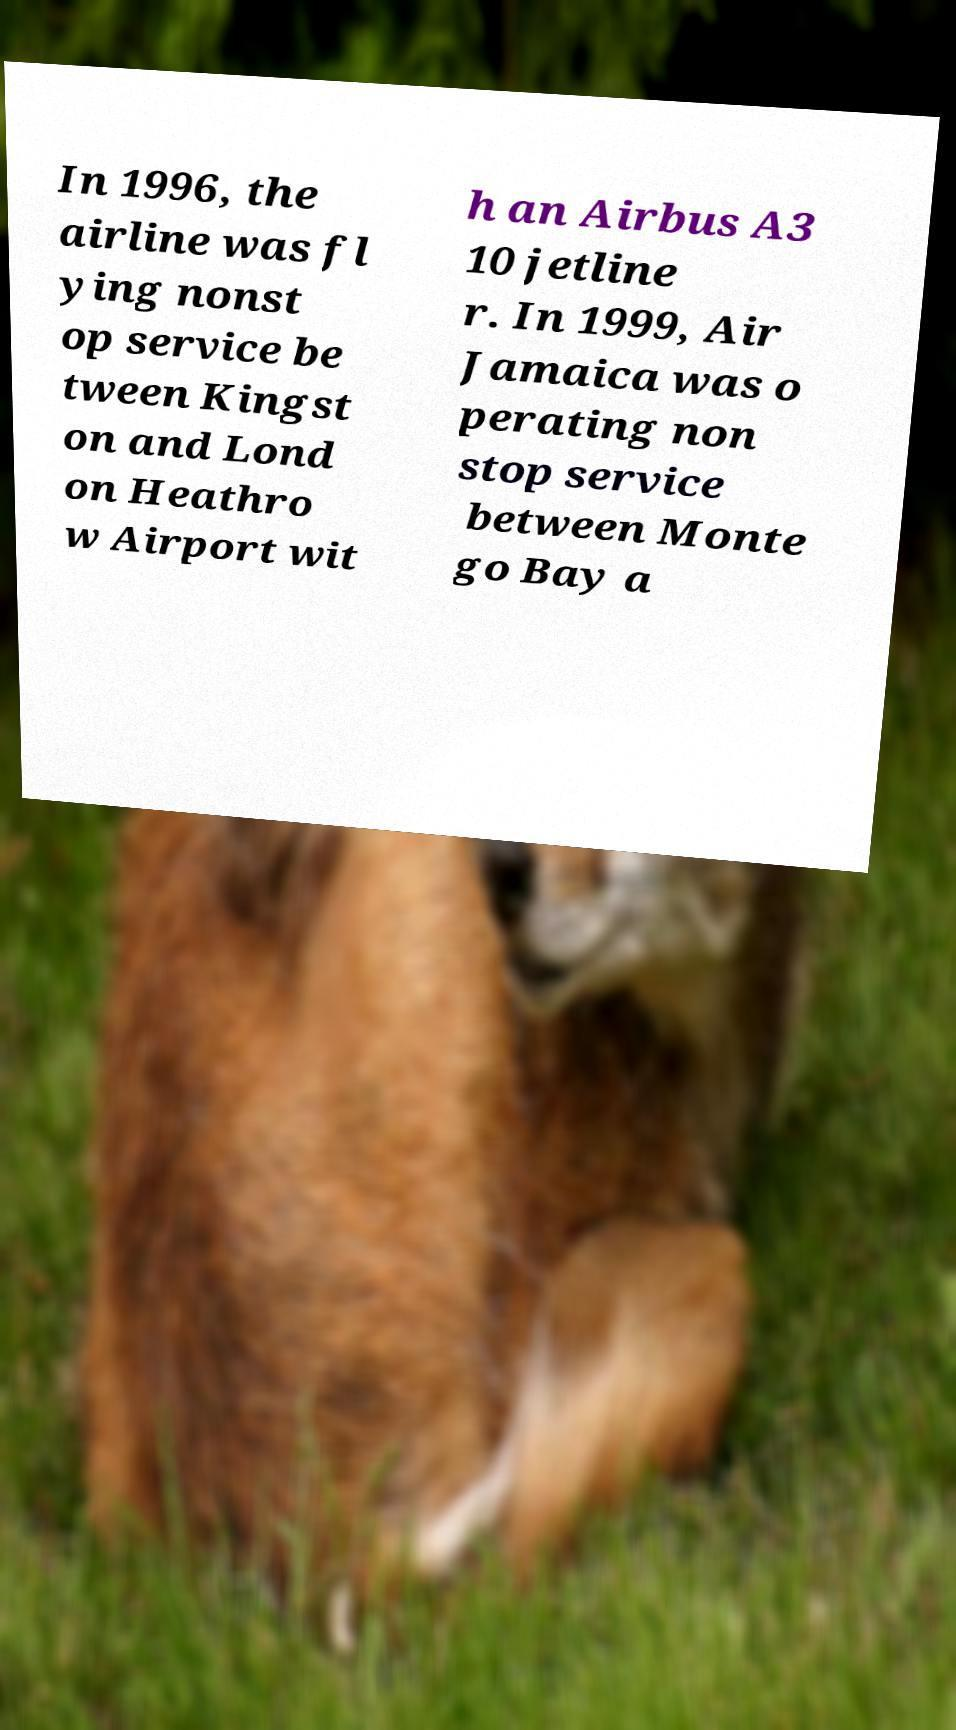What messages or text are displayed in this image? I need them in a readable, typed format. In 1996, the airline was fl ying nonst op service be tween Kingst on and Lond on Heathro w Airport wit h an Airbus A3 10 jetline r. In 1999, Air Jamaica was o perating non stop service between Monte go Bay a 